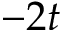<formula> <loc_0><loc_0><loc_500><loc_500>- 2 t</formula> 